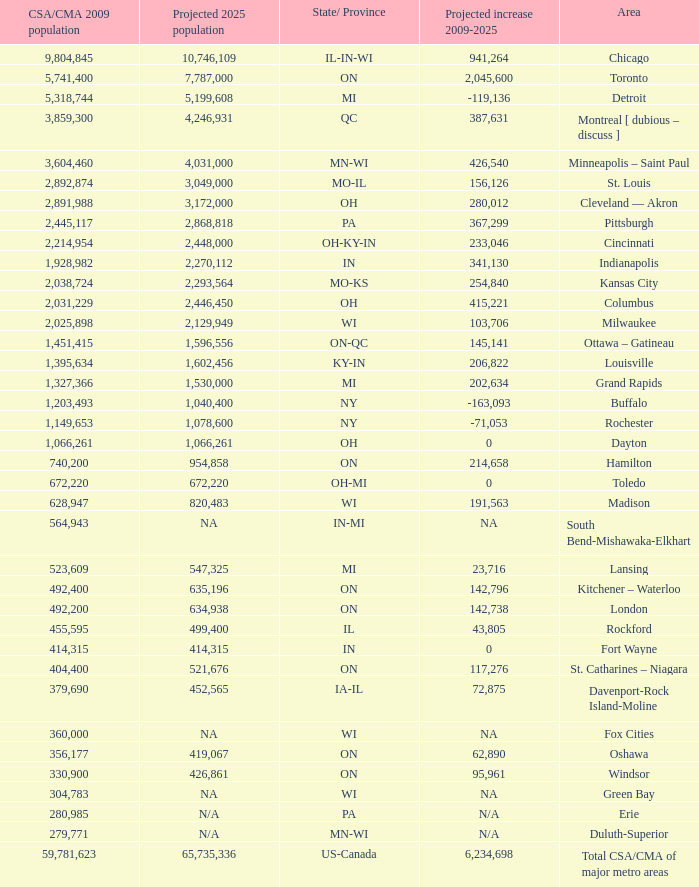What's the CSA/CMA Population in IA-IL? 379690.0. Parse the table in full. {'header': ['CSA/CMA 2009 population', 'Projected 2025 population', 'State/ Province', 'Projected increase 2009-2025', 'Area'], 'rows': [['9,804,845', '10,746,109', 'IL-IN-WI', '941,264', 'Chicago'], ['5,741,400', '7,787,000', 'ON', '2,045,600', 'Toronto'], ['5,318,744', '5,199,608', 'MI', '-119,136', 'Detroit'], ['3,859,300', '4,246,931', 'QC', '387,631', 'Montreal [ dubious – discuss ]'], ['3,604,460', '4,031,000', 'MN-WI', '426,540', 'Minneapolis – Saint Paul'], ['2,892,874', '3,049,000', 'MO-IL', '156,126', 'St. Louis'], ['2,891,988', '3,172,000', 'OH', '280,012', 'Cleveland — Akron'], ['2,445,117', '2,868,818', 'PA', '367,299', 'Pittsburgh'], ['2,214,954', '2,448,000', 'OH-KY-IN', '233,046', 'Cincinnati'], ['1,928,982', '2,270,112', 'IN', '341,130', 'Indianapolis'], ['2,038,724', '2,293,564', 'MO-KS', '254,840', 'Kansas City'], ['2,031,229', '2,446,450', 'OH', '415,221', 'Columbus'], ['2,025,898', '2,129,949', 'WI', '103,706', 'Milwaukee'], ['1,451,415', '1,596,556', 'ON-QC', '145,141', 'Ottawa – Gatineau'], ['1,395,634', '1,602,456', 'KY-IN', '206,822', 'Louisville'], ['1,327,366', '1,530,000', 'MI', '202,634', 'Grand Rapids'], ['1,203,493', '1,040,400', 'NY', '-163,093', 'Buffalo'], ['1,149,653', '1,078,600', 'NY', '-71,053', 'Rochester'], ['1,066,261', '1,066,261', 'OH', '0', 'Dayton'], ['740,200', '954,858', 'ON', '214,658', 'Hamilton'], ['672,220', '672,220', 'OH-MI', '0', 'Toledo'], ['628,947', '820,483', 'WI', '191,563', 'Madison'], ['564,943', 'NA', 'IN-MI', 'NA', 'South Bend-Mishawaka-Elkhart'], ['523,609', '547,325', 'MI', '23,716', 'Lansing'], ['492,400', '635,196', 'ON', '142,796', 'Kitchener – Waterloo'], ['492,200', '634,938', 'ON', '142,738', 'London'], ['455,595', '499,400', 'IL', '43,805', 'Rockford'], ['414,315', '414,315', 'IN', '0', 'Fort Wayne'], ['404,400', '521,676', 'ON', '117,276', 'St. Catharines – Niagara'], ['379,690', '452,565', 'IA-IL', '72,875', 'Davenport-Rock Island-Moline'], ['360,000', 'NA', 'WI', 'NA', 'Fox Cities'], ['356,177', '419,067', 'ON', '62,890', 'Oshawa'], ['330,900', '426,861', 'ON', '95,961', 'Windsor'], ['304,783', 'NA', 'WI', 'NA', 'Green Bay'], ['280,985', 'N/A', 'PA', 'N/A', 'Erie'], ['279,771', 'N/A', 'MN-WI', 'N/A', 'Duluth-Superior'], ['59,781,623', '65,735,336', 'US-Canada', '6,234,698', 'Total CSA/CMA of major metro areas']]} 